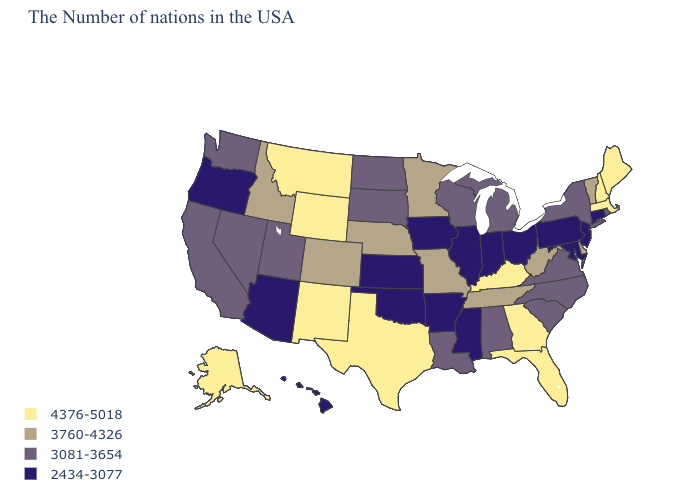Name the states that have a value in the range 4376-5018?
Concise answer only. Maine, Massachusetts, New Hampshire, Florida, Georgia, Kentucky, Texas, Wyoming, New Mexico, Montana, Alaska. Does Michigan have the lowest value in the MidWest?
Give a very brief answer. No. Name the states that have a value in the range 2434-3077?
Answer briefly. Connecticut, New Jersey, Maryland, Pennsylvania, Ohio, Indiana, Illinois, Mississippi, Arkansas, Iowa, Kansas, Oklahoma, Arizona, Oregon, Hawaii. Which states have the lowest value in the South?
Give a very brief answer. Maryland, Mississippi, Arkansas, Oklahoma. Among the states that border Iowa , does Illinois have the lowest value?
Concise answer only. Yes. Does New Jersey have the lowest value in the Northeast?
Give a very brief answer. Yes. Which states have the lowest value in the USA?
Write a very short answer. Connecticut, New Jersey, Maryland, Pennsylvania, Ohio, Indiana, Illinois, Mississippi, Arkansas, Iowa, Kansas, Oklahoma, Arizona, Oregon, Hawaii. Name the states that have a value in the range 3081-3654?
Write a very short answer. Rhode Island, New York, Virginia, North Carolina, South Carolina, Michigan, Alabama, Wisconsin, Louisiana, South Dakota, North Dakota, Utah, Nevada, California, Washington. Does Maine have the lowest value in the USA?
Short answer required. No. What is the value of Massachusetts?
Short answer required. 4376-5018. What is the value of Rhode Island?
Short answer required. 3081-3654. Name the states that have a value in the range 3760-4326?
Give a very brief answer. Vermont, Delaware, West Virginia, Tennessee, Missouri, Minnesota, Nebraska, Colorado, Idaho. Is the legend a continuous bar?
Short answer required. No. Name the states that have a value in the range 3081-3654?
Give a very brief answer. Rhode Island, New York, Virginia, North Carolina, South Carolina, Michigan, Alabama, Wisconsin, Louisiana, South Dakota, North Dakota, Utah, Nevada, California, Washington. Does Oregon have the lowest value in the West?
Answer briefly. Yes. 